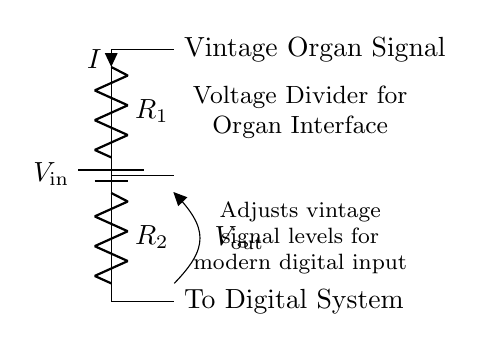What are the values of the resistors? The resistor values are not given explicitly in the diagram. However, they're labeled as R1 and R2, indicating they are the components used in the voltage divider circuit.
Answer: R1, R2 What is the purpose of this circuit? The circuit's purpose, described in the labels, is to adjust vintage organ signal levels for modern digital input, enabling compatibility between old components and new systems.
Answer: Signal level adjustment What is the input voltage designator? The input voltage is indicated by the label V_in next to the battery symbol, which provides the voltage supply to the circuit.
Answer: V_in What is the output voltage dependent on? The output voltage, labeled as V_out, depends on the values of R1 and R2, according to the voltage divider rule. This rule states that V_out is a fraction of V_in determined by the resistor values' ratio.
Answer: R1, R2 What type of circuit is this? The circuit is a voltage divider, which specifically uses two resistors to divide the input voltage into a lower output voltage suitable for interfacing.
Answer: Voltage divider How does current flow through the circuit? Current flows from the battery, through R1 to R2, and then out of the circuit to the digital system. This is a series circuit, so the same current I flows through both resistors.
Answer: In series 